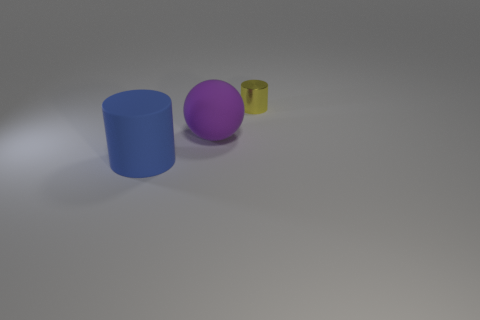Is there any other thing that has the same material as the yellow object?
Give a very brief answer. No. There is a rubber object that is behind the large blue object; is it the same color as the metallic thing?
Offer a terse response. No. How many things are cylinders that are to the right of the large rubber cylinder or small objects?
Your answer should be very brief. 1. There is a thing that is in front of the matte object that is behind the cylinder on the left side of the purple rubber object; what is its material?
Offer a terse response. Rubber. Are there more spheres in front of the purple matte thing than large rubber objects that are to the right of the tiny object?
Make the answer very short. No. What number of cylinders are large blue objects or small objects?
Provide a succinct answer. 2. How many matte things are behind the cylinder that is behind the cylinder left of the small yellow shiny cylinder?
Provide a succinct answer. 0. Are there more yellow objects than big green objects?
Offer a very short reply. Yes. Is the metal cylinder the same size as the matte ball?
Offer a very short reply. No. How many objects are either purple metallic objects or large rubber things?
Give a very brief answer. 2. 